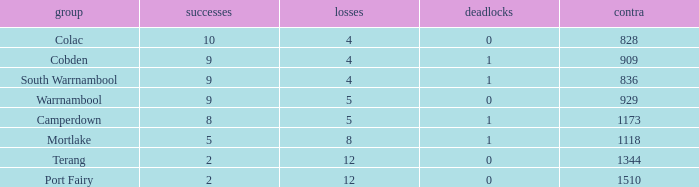What is the sum of wins for Port Fairy with under 1510 against? None. 